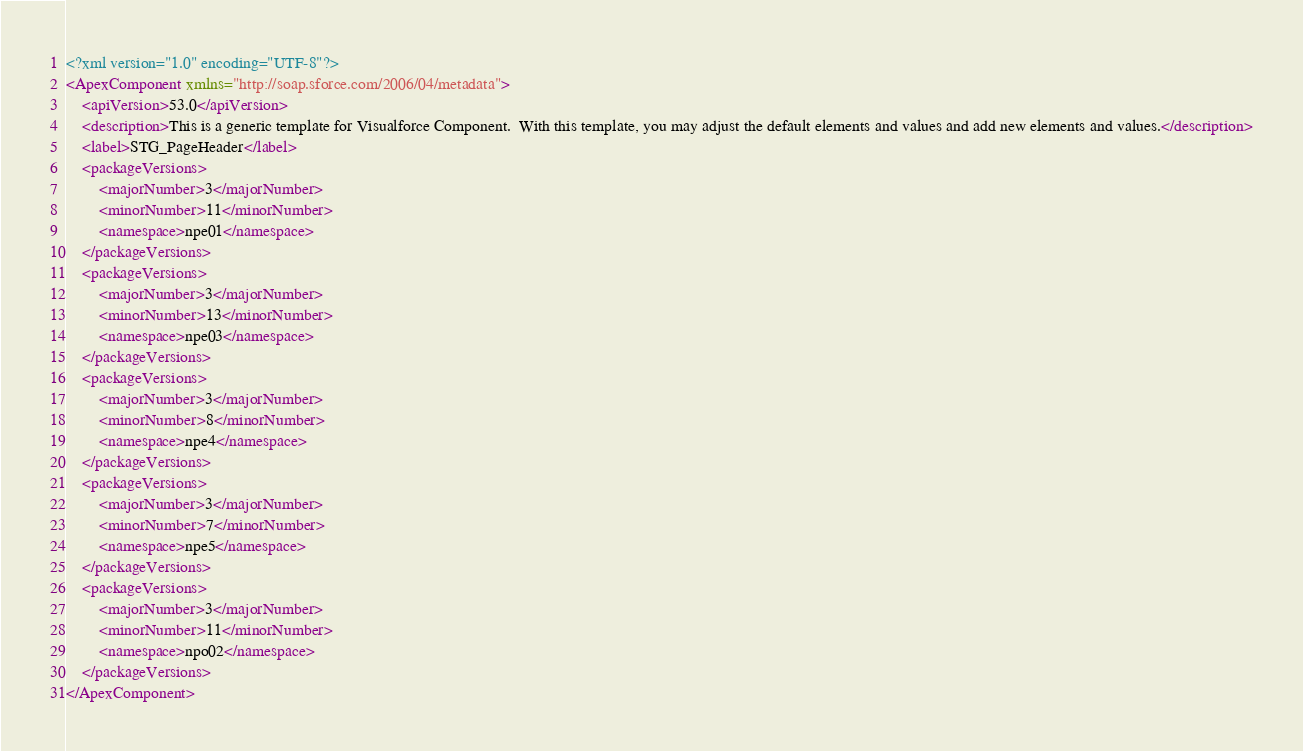<code> <loc_0><loc_0><loc_500><loc_500><_XML_><?xml version="1.0" encoding="UTF-8"?>
<ApexComponent xmlns="http://soap.sforce.com/2006/04/metadata">
    <apiVersion>53.0</apiVersion>
    <description>This is a generic template for Visualforce Component.  With this template, you may adjust the default elements and values and add new elements and values.</description>
    <label>STG_PageHeader</label>
    <packageVersions>
        <majorNumber>3</majorNumber>
        <minorNumber>11</minorNumber>
        <namespace>npe01</namespace>
    </packageVersions>
    <packageVersions>
        <majorNumber>3</majorNumber>
        <minorNumber>13</minorNumber>
        <namespace>npe03</namespace>
    </packageVersions>
    <packageVersions>
        <majorNumber>3</majorNumber>
        <minorNumber>8</minorNumber>
        <namespace>npe4</namespace>
    </packageVersions>
    <packageVersions>
        <majorNumber>3</majorNumber>
        <minorNumber>7</minorNumber>
        <namespace>npe5</namespace>
    </packageVersions>
    <packageVersions>
        <majorNumber>3</majorNumber>
        <minorNumber>11</minorNumber>
        <namespace>npo02</namespace>
    </packageVersions>
</ApexComponent>
</code> 